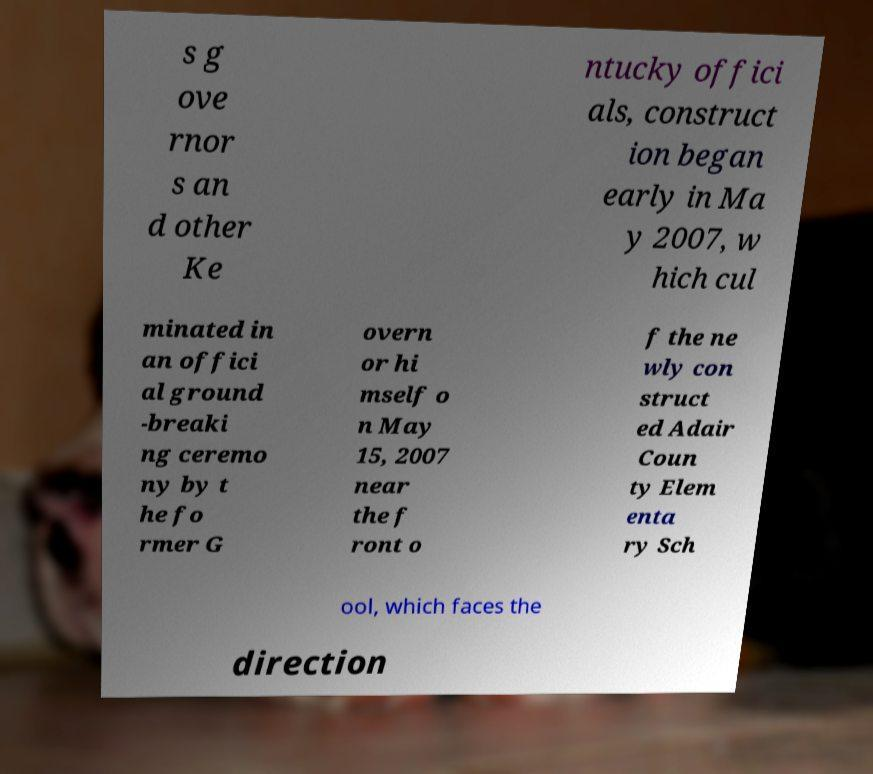Please identify and transcribe the text found in this image. s g ove rnor s an d other Ke ntucky offici als, construct ion began early in Ma y 2007, w hich cul minated in an offici al ground -breaki ng ceremo ny by t he fo rmer G overn or hi mself o n May 15, 2007 near the f ront o f the ne wly con struct ed Adair Coun ty Elem enta ry Sch ool, which faces the direction 